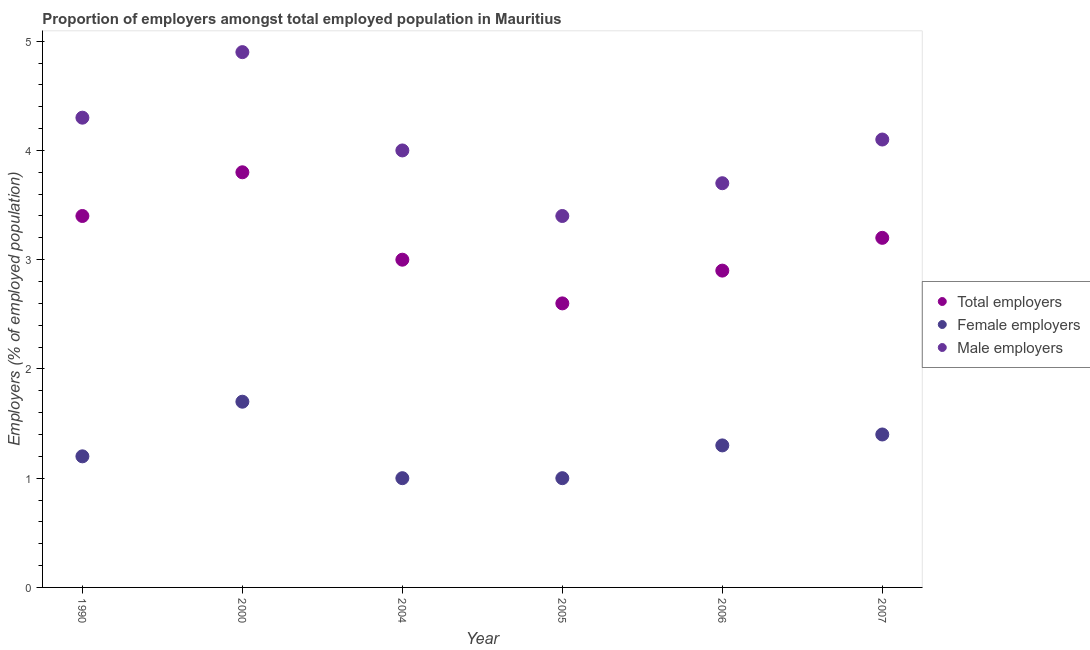How many different coloured dotlines are there?
Keep it short and to the point. 3. Is the number of dotlines equal to the number of legend labels?
Offer a very short reply. Yes. What is the percentage of female employers in 2007?
Provide a short and direct response. 1.4. Across all years, what is the maximum percentage of total employers?
Provide a succinct answer. 3.8. Across all years, what is the minimum percentage of total employers?
Provide a short and direct response. 2.6. In which year was the percentage of total employers maximum?
Give a very brief answer. 2000. In which year was the percentage of male employers minimum?
Ensure brevity in your answer.  2005. What is the total percentage of male employers in the graph?
Give a very brief answer. 24.4. What is the difference between the percentage of female employers in 1990 and that in 2006?
Your answer should be compact. -0.1. What is the difference between the percentage of total employers in 2006 and the percentage of male employers in 1990?
Offer a very short reply. -1.4. What is the average percentage of total employers per year?
Keep it short and to the point. 3.15. In the year 2007, what is the difference between the percentage of female employers and percentage of male employers?
Offer a terse response. -2.7. In how many years, is the percentage of female employers greater than 1 %?
Ensure brevity in your answer.  4. What is the ratio of the percentage of male employers in 2000 to that in 2006?
Keep it short and to the point. 1.32. Is the percentage of total employers in 2004 less than that in 2007?
Your answer should be very brief. Yes. What is the difference between the highest and the second highest percentage of female employers?
Provide a succinct answer. 0.3. What is the difference between the highest and the lowest percentage of female employers?
Offer a very short reply. 0.7. In how many years, is the percentage of female employers greater than the average percentage of female employers taken over all years?
Offer a very short reply. 3. Is the percentage of male employers strictly less than the percentage of total employers over the years?
Keep it short and to the point. No. How many dotlines are there?
Offer a terse response. 3. How many years are there in the graph?
Provide a short and direct response. 6. Where does the legend appear in the graph?
Your answer should be compact. Center right. How many legend labels are there?
Keep it short and to the point. 3. How are the legend labels stacked?
Provide a succinct answer. Vertical. What is the title of the graph?
Your response must be concise. Proportion of employers amongst total employed population in Mauritius. Does "Textiles and clothing" appear as one of the legend labels in the graph?
Ensure brevity in your answer.  No. What is the label or title of the Y-axis?
Make the answer very short. Employers (% of employed population). What is the Employers (% of employed population) of Total employers in 1990?
Ensure brevity in your answer.  3.4. What is the Employers (% of employed population) in Female employers in 1990?
Give a very brief answer. 1.2. What is the Employers (% of employed population) in Male employers in 1990?
Keep it short and to the point. 4.3. What is the Employers (% of employed population) of Total employers in 2000?
Your answer should be very brief. 3.8. What is the Employers (% of employed population) of Female employers in 2000?
Provide a succinct answer. 1.7. What is the Employers (% of employed population) in Male employers in 2000?
Offer a terse response. 4.9. What is the Employers (% of employed population) in Total employers in 2005?
Your answer should be very brief. 2.6. What is the Employers (% of employed population) in Male employers in 2005?
Offer a terse response. 3.4. What is the Employers (% of employed population) in Total employers in 2006?
Ensure brevity in your answer.  2.9. What is the Employers (% of employed population) of Female employers in 2006?
Provide a short and direct response. 1.3. What is the Employers (% of employed population) in Male employers in 2006?
Your answer should be very brief. 3.7. What is the Employers (% of employed population) of Total employers in 2007?
Ensure brevity in your answer.  3.2. What is the Employers (% of employed population) in Female employers in 2007?
Provide a short and direct response. 1.4. What is the Employers (% of employed population) of Male employers in 2007?
Provide a succinct answer. 4.1. Across all years, what is the maximum Employers (% of employed population) of Total employers?
Give a very brief answer. 3.8. Across all years, what is the maximum Employers (% of employed population) in Female employers?
Provide a short and direct response. 1.7. Across all years, what is the maximum Employers (% of employed population) of Male employers?
Your answer should be compact. 4.9. Across all years, what is the minimum Employers (% of employed population) in Total employers?
Give a very brief answer. 2.6. Across all years, what is the minimum Employers (% of employed population) of Female employers?
Give a very brief answer. 1. Across all years, what is the minimum Employers (% of employed population) in Male employers?
Provide a short and direct response. 3.4. What is the total Employers (% of employed population) in Total employers in the graph?
Your answer should be very brief. 18.9. What is the total Employers (% of employed population) of Female employers in the graph?
Your response must be concise. 7.6. What is the total Employers (% of employed population) in Male employers in the graph?
Provide a short and direct response. 24.4. What is the difference between the Employers (% of employed population) in Female employers in 1990 and that in 2000?
Your answer should be compact. -0.5. What is the difference between the Employers (% of employed population) in Male employers in 1990 and that in 2000?
Your response must be concise. -0.6. What is the difference between the Employers (% of employed population) in Female employers in 1990 and that in 2004?
Offer a very short reply. 0.2. What is the difference between the Employers (% of employed population) in Male employers in 1990 and that in 2004?
Give a very brief answer. 0.3. What is the difference between the Employers (% of employed population) in Total employers in 1990 and that in 2005?
Provide a short and direct response. 0.8. What is the difference between the Employers (% of employed population) in Male employers in 1990 and that in 2005?
Keep it short and to the point. 0.9. What is the difference between the Employers (% of employed population) in Female employers in 1990 and that in 2006?
Keep it short and to the point. -0.1. What is the difference between the Employers (% of employed population) of Male employers in 1990 and that in 2006?
Offer a terse response. 0.6. What is the difference between the Employers (% of employed population) in Total employers in 1990 and that in 2007?
Keep it short and to the point. 0.2. What is the difference between the Employers (% of employed population) in Female employers in 1990 and that in 2007?
Offer a terse response. -0.2. What is the difference between the Employers (% of employed population) of Female employers in 2000 and that in 2004?
Offer a terse response. 0.7. What is the difference between the Employers (% of employed population) in Male employers in 2000 and that in 2004?
Offer a very short reply. 0.9. What is the difference between the Employers (% of employed population) in Female employers in 2000 and that in 2006?
Keep it short and to the point. 0.4. What is the difference between the Employers (% of employed population) of Male employers in 2000 and that in 2006?
Offer a very short reply. 1.2. What is the difference between the Employers (% of employed population) in Total employers in 2000 and that in 2007?
Offer a very short reply. 0.6. What is the difference between the Employers (% of employed population) of Female employers in 2000 and that in 2007?
Ensure brevity in your answer.  0.3. What is the difference between the Employers (% of employed population) in Male employers in 2000 and that in 2007?
Offer a terse response. 0.8. What is the difference between the Employers (% of employed population) of Female employers in 2004 and that in 2005?
Provide a succinct answer. 0. What is the difference between the Employers (% of employed population) in Male employers in 2004 and that in 2006?
Your response must be concise. 0.3. What is the difference between the Employers (% of employed population) of Total employers in 2004 and that in 2007?
Your answer should be very brief. -0.2. What is the difference between the Employers (% of employed population) of Male employers in 2004 and that in 2007?
Your answer should be compact. -0.1. What is the difference between the Employers (% of employed population) in Female employers in 2005 and that in 2006?
Keep it short and to the point. -0.3. What is the difference between the Employers (% of employed population) of Female employers in 2005 and that in 2007?
Your answer should be compact. -0.4. What is the difference between the Employers (% of employed population) in Female employers in 2006 and that in 2007?
Offer a terse response. -0.1. What is the difference between the Employers (% of employed population) of Male employers in 2006 and that in 2007?
Offer a terse response. -0.4. What is the difference between the Employers (% of employed population) of Total employers in 1990 and the Employers (% of employed population) of Female employers in 2000?
Offer a very short reply. 1.7. What is the difference between the Employers (% of employed population) of Total employers in 1990 and the Employers (% of employed population) of Male employers in 2000?
Your answer should be very brief. -1.5. What is the difference between the Employers (% of employed population) of Female employers in 1990 and the Employers (% of employed population) of Male employers in 2000?
Give a very brief answer. -3.7. What is the difference between the Employers (% of employed population) in Total employers in 1990 and the Employers (% of employed population) in Female employers in 2005?
Keep it short and to the point. 2.4. What is the difference between the Employers (% of employed population) of Total employers in 1990 and the Employers (% of employed population) of Male employers in 2005?
Your response must be concise. 0. What is the difference between the Employers (% of employed population) of Female employers in 1990 and the Employers (% of employed population) of Male employers in 2005?
Offer a terse response. -2.2. What is the difference between the Employers (% of employed population) of Total employers in 1990 and the Employers (% of employed population) of Female employers in 2007?
Provide a succinct answer. 2. What is the difference between the Employers (% of employed population) in Total employers in 1990 and the Employers (% of employed population) in Male employers in 2007?
Offer a terse response. -0.7. What is the difference between the Employers (% of employed population) in Female employers in 1990 and the Employers (% of employed population) in Male employers in 2007?
Make the answer very short. -2.9. What is the difference between the Employers (% of employed population) of Total employers in 2000 and the Employers (% of employed population) of Male employers in 2004?
Give a very brief answer. -0.2. What is the difference between the Employers (% of employed population) in Total employers in 2000 and the Employers (% of employed population) in Male employers in 2005?
Give a very brief answer. 0.4. What is the difference between the Employers (% of employed population) in Female employers in 2000 and the Employers (% of employed population) in Male employers in 2005?
Your answer should be very brief. -1.7. What is the difference between the Employers (% of employed population) of Total employers in 2000 and the Employers (% of employed population) of Female employers in 2007?
Your answer should be very brief. 2.4. What is the difference between the Employers (% of employed population) of Total employers in 2004 and the Employers (% of employed population) of Female employers in 2005?
Offer a very short reply. 2. What is the difference between the Employers (% of employed population) of Female employers in 2004 and the Employers (% of employed population) of Male employers in 2005?
Make the answer very short. -2.4. What is the difference between the Employers (% of employed population) of Total employers in 2004 and the Employers (% of employed population) of Female employers in 2006?
Your answer should be very brief. 1.7. What is the difference between the Employers (% of employed population) of Total employers in 2004 and the Employers (% of employed population) of Female employers in 2007?
Your answer should be compact. 1.6. What is the difference between the Employers (% of employed population) in Total employers in 2004 and the Employers (% of employed population) in Male employers in 2007?
Provide a succinct answer. -1.1. What is the difference between the Employers (% of employed population) in Total employers in 2005 and the Employers (% of employed population) in Male employers in 2006?
Keep it short and to the point. -1.1. What is the difference between the Employers (% of employed population) of Total employers in 2006 and the Employers (% of employed population) of Female employers in 2007?
Ensure brevity in your answer.  1.5. What is the average Employers (% of employed population) of Total employers per year?
Give a very brief answer. 3.15. What is the average Employers (% of employed population) of Female employers per year?
Your answer should be very brief. 1.27. What is the average Employers (% of employed population) of Male employers per year?
Give a very brief answer. 4.07. In the year 1990, what is the difference between the Employers (% of employed population) of Total employers and Employers (% of employed population) of Female employers?
Provide a succinct answer. 2.2. In the year 1990, what is the difference between the Employers (% of employed population) in Total employers and Employers (% of employed population) in Male employers?
Your answer should be very brief. -0.9. In the year 2000, what is the difference between the Employers (% of employed population) in Total employers and Employers (% of employed population) in Female employers?
Make the answer very short. 2.1. In the year 2000, what is the difference between the Employers (% of employed population) of Female employers and Employers (% of employed population) of Male employers?
Your answer should be very brief. -3.2. In the year 2005, what is the difference between the Employers (% of employed population) in Total employers and Employers (% of employed population) in Female employers?
Make the answer very short. 1.6. In the year 2005, what is the difference between the Employers (% of employed population) of Total employers and Employers (% of employed population) of Male employers?
Offer a very short reply. -0.8. In the year 2005, what is the difference between the Employers (% of employed population) in Female employers and Employers (% of employed population) in Male employers?
Keep it short and to the point. -2.4. In the year 2006, what is the difference between the Employers (% of employed population) in Total employers and Employers (% of employed population) in Female employers?
Keep it short and to the point. 1.6. In the year 2007, what is the difference between the Employers (% of employed population) in Female employers and Employers (% of employed population) in Male employers?
Provide a short and direct response. -2.7. What is the ratio of the Employers (% of employed population) of Total employers in 1990 to that in 2000?
Provide a succinct answer. 0.89. What is the ratio of the Employers (% of employed population) of Female employers in 1990 to that in 2000?
Your answer should be very brief. 0.71. What is the ratio of the Employers (% of employed population) in Male employers in 1990 to that in 2000?
Offer a terse response. 0.88. What is the ratio of the Employers (% of employed population) in Total employers in 1990 to that in 2004?
Provide a short and direct response. 1.13. What is the ratio of the Employers (% of employed population) of Female employers in 1990 to that in 2004?
Keep it short and to the point. 1.2. What is the ratio of the Employers (% of employed population) in Male employers in 1990 to that in 2004?
Offer a very short reply. 1.07. What is the ratio of the Employers (% of employed population) in Total employers in 1990 to that in 2005?
Keep it short and to the point. 1.31. What is the ratio of the Employers (% of employed population) of Male employers in 1990 to that in 2005?
Keep it short and to the point. 1.26. What is the ratio of the Employers (% of employed population) of Total employers in 1990 to that in 2006?
Provide a short and direct response. 1.17. What is the ratio of the Employers (% of employed population) of Male employers in 1990 to that in 2006?
Offer a very short reply. 1.16. What is the ratio of the Employers (% of employed population) in Male employers in 1990 to that in 2007?
Offer a very short reply. 1.05. What is the ratio of the Employers (% of employed population) of Total employers in 2000 to that in 2004?
Your response must be concise. 1.27. What is the ratio of the Employers (% of employed population) in Male employers in 2000 to that in 2004?
Provide a succinct answer. 1.23. What is the ratio of the Employers (% of employed population) in Total employers in 2000 to that in 2005?
Provide a short and direct response. 1.46. What is the ratio of the Employers (% of employed population) of Female employers in 2000 to that in 2005?
Keep it short and to the point. 1.7. What is the ratio of the Employers (% of employed population) in Male employers in 2000 to that in 2005?
Ensure brevity in your answer.  1.44. What is the ratio of the Employers (% of employed population) of Total employers in 2000 to that in 2006?
Offer a very short reply. 1.31. What is the ratio of the Employers (% of employed population) of Female employers in 2000 to that in 2006?
Offer a terse response. 1.31. What is the ratio of the Employers (% of employed population) in Male employers in 2000 to that in 2006?
Your response must be concise. 1.32. What is the ratio of the Employers (% of employed population) in Total employers in 2000 to that in 2007?
Keep it short and to the point. 1.19. What is the ratio of the Employers (% of employed population) in Female employers in 2000 to that in 2007?
Your answer should be compact. 1.21. What is the ratio of the Employers (% of employed population) of Male employers in 2000 to that in 2007?
Offer a very short reply. 1.2. What is the ratio of the Employers (% of employed population) of Total employers in 2004 to that in 2005?
Your response must be concise. 1.15. What is the ratio of the Employers (% of employed population) in Male employers in 2004 to that in 2005?
Offer a very short reply. 1.18. What is the ratio of the Employers (% of employed population) in Total employers in 2004 to that in 2006?
Offer a terse response. 1.03. What is the ratio of the Employers (% of employed population) of Female employers in 2004 to that in 2006?
Keep it short and to the point. 0.77. What is the ratio of the Employers (% of employed population) of Male employers in 2004 to that in 2006?
Ensure brevity in your answer.  1.08. What is the ratio of the Employers (% of employed population) in Male employers in 2004 to that in 2007?
Your response must be concise. 0.98. What is the ratio of the Employers (% of employed population) in Total employers in 2005 to that in 2006?
Your answer should be very brief. 0.9. What is the ratio of the Employers (% of employed population) in Female employers in 2005 to that in 2006?
Ensure brevity in your answer.  0.77. What is the ratio of the Employers (% of employed population) of Male employers in 2005 to that in 2006?
Give a very brief answer. 0.92. What is the ratio of the Employers (% of employed population) in Total employers in 2005 to that in 2007?
Provide a short and direct response. 0.81. What is the ratio of the Employers (% of employed population) in Male employers in 2005 to that in 2007?
Ensure brevity in your answer.  0.83. What is the ratio of the Employers (% of employed population) in Total employers in 2006 to that in 2007?
Your response must be concise. 0.91. What is the ratio of the Employers (% of employed population) of Male employers in 2006 to that in 2007?
Offer a very short reply. 0.9. What is the difference between the highest and the second highest Employers (% of employed population) of Total employers?
Offer a terse response. 0.4. What is the difference between the highest and the second highest Employers (% of employed population) of Female employers?
Provide a short and direct response. 0.3. What is the difference between the highest and the lowest Employers (% of employed population) in Female employers?
Provide a short and direct response. 0.7. What is the difference between the highest and the lowest Employers (% of employed population) in Male employers?
Give a very brief answer. 1.5. 